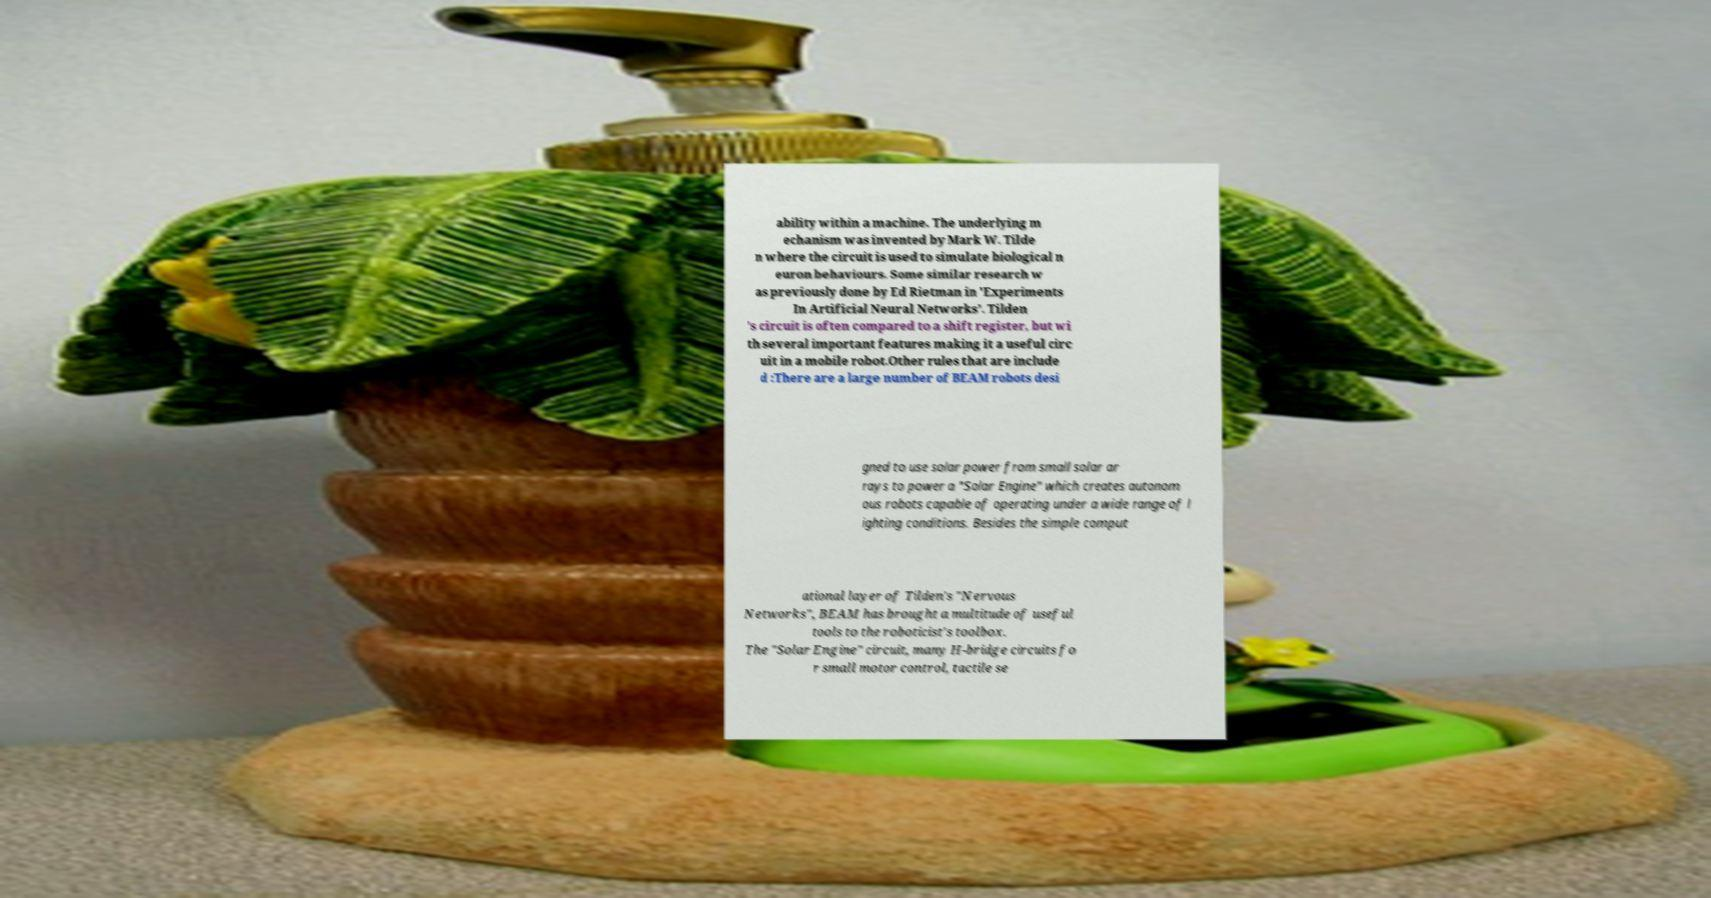Please read and relay the text visible in this image. What does it say? ability within a machine. The underlying m echanism was invented by Mark W. Tilde n where the circuit is used to simulate biological n euron behaviours. Some similar research w as previously done by Ed Rietman in 'Experiments In Artificial Neural Networks'. Tilden 's circuit is often compared to a shift register, but wi th several important features making it a useful circ uit in a mobile robot.Other rules that are include d :There are a large number of BEAM robots desi gned to use solar power from small solar ar rays to power a "Solar Engine" which creates autonom ous robots capable of operating under a wide range of l ighting conditions. Besides the simple comput ational layer of Tilden's "Nervous Networks", BEAM has brought a multitude of useful tools to the roboticist's toolbox. The "Solar Engine" circuit, many H-bridge circuits fo r small motor control, tactile se 